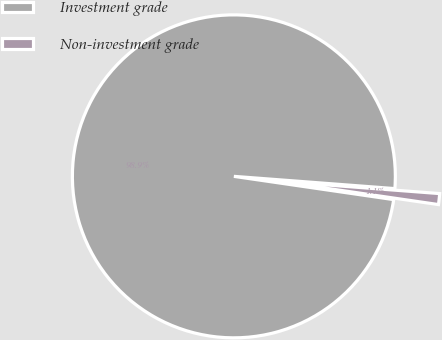Convert chart. <chart><loc_0><loc_0><loc_500><loc_500><pie_chart><fcel>Investment grade<fcel>Non-investment grade<nl><fcel>98.91%<fcel>1.09%<nl></chart> 